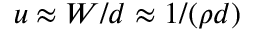<formula> <loc_0><loc_0><loc_500><loc_500>u \approx W / d \approx 1 / ( \rho d )</formula> 